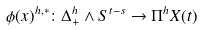Convert formula to latex. <formula><loc_0><loc_0><loc_500><loc_500>\phi ( x ) ^ { h , * } \colon \Delta ^ { h } _ { + } \wedge S ^ { t - s } \rightarrow \Pi ^ { h } X ( t )</formula> 